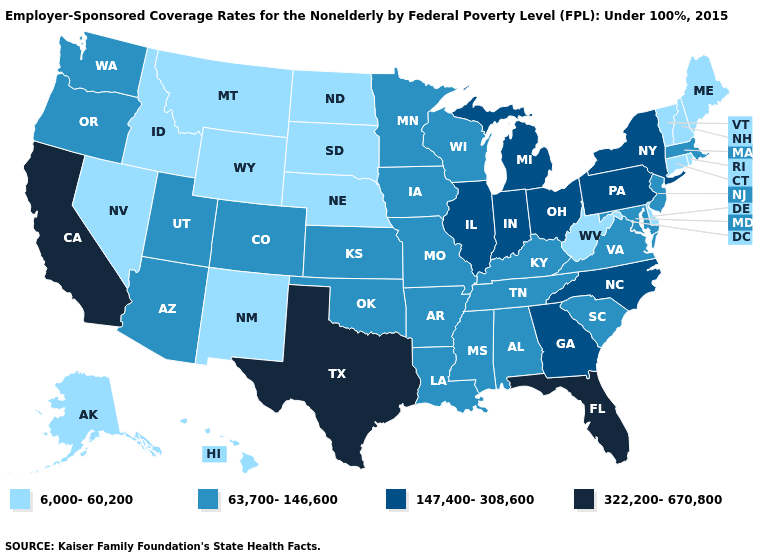What is the highest value in the USA?
Concise answer only. 322,200-670,800. Does the map have missing data?
Concise answer only. No. Among the states that border Texas , which have the highest value?
Keep it brief. Arkansas, Louisiana, Oklahoma. Among the states that border Idaho , which have the highest value?
Concise answer only. Oregon, Utah, Washington. Name the states that have a value in the range 6,000-60,200?
Short answer required. Alaska, Connecticut, Delaware, Hawaii, Idaho, Maine, Montana, Nebraska, Nevada, New Hampshire, New Mexico, North Dakota, Rhode Island, South Dakota, Vermont, West Virginia, Wyoming. Name the states that have a value in the range 6,000-60,200?
Quick response, please. Alaska, Connecticut, Delaware, Hawaii, Idaho, Maine, Montana, Nebraska, Nevada, New Hampshire, New Mexico, North Dakota, Rhode Island, South Dakota, Vermont, West Virginia, Wyoming. What is the lowest value in the MidWest?
Be succinct. 6,000-60,200. Which states have the lowest value in the USA?
Keep it brief. Alaska, Connecticut, Delaware, Hawaii, Idaho, Maine, Montana, Nebraska, Nevada, New Hampshire, New Mexico, North Dakota, Rhode Island, South Dakota, Vermont, West Virginia, Wyoming. What is the value of Mississippi?
Give a very brief answer. 63,700-146,600. Among the states that border Vermont , which have the lowest value?
Short answer required. New Hampshire. Among the states that border Nebraska , which have the highest value?
Quick response, please. Colorado, Iowa, Kansas, Missouri. Name the states that have a value in the range 147,400-308,600?
Be succinct. Georgia, Illinois, Indiana, Michigan, New York, North Carolina, Ohio, Pennsylvania. Name the states that have a value in the range 6,000-60,200?
Keep it brief. Alaska, Connecticut, Delaware, Hawaii, Idaho, Maine, Montana, Nebraska, Nevada, New Hampshire, New Mexico, North Dakota, Rhode Island, South Dakota, Vermont, West Virginia, Wyoming. What is the value of West Virginia?
Answer briefly. 6,000-60,200. What is the value of Mississippi?
Quick response, please. 63,700-146,600. 